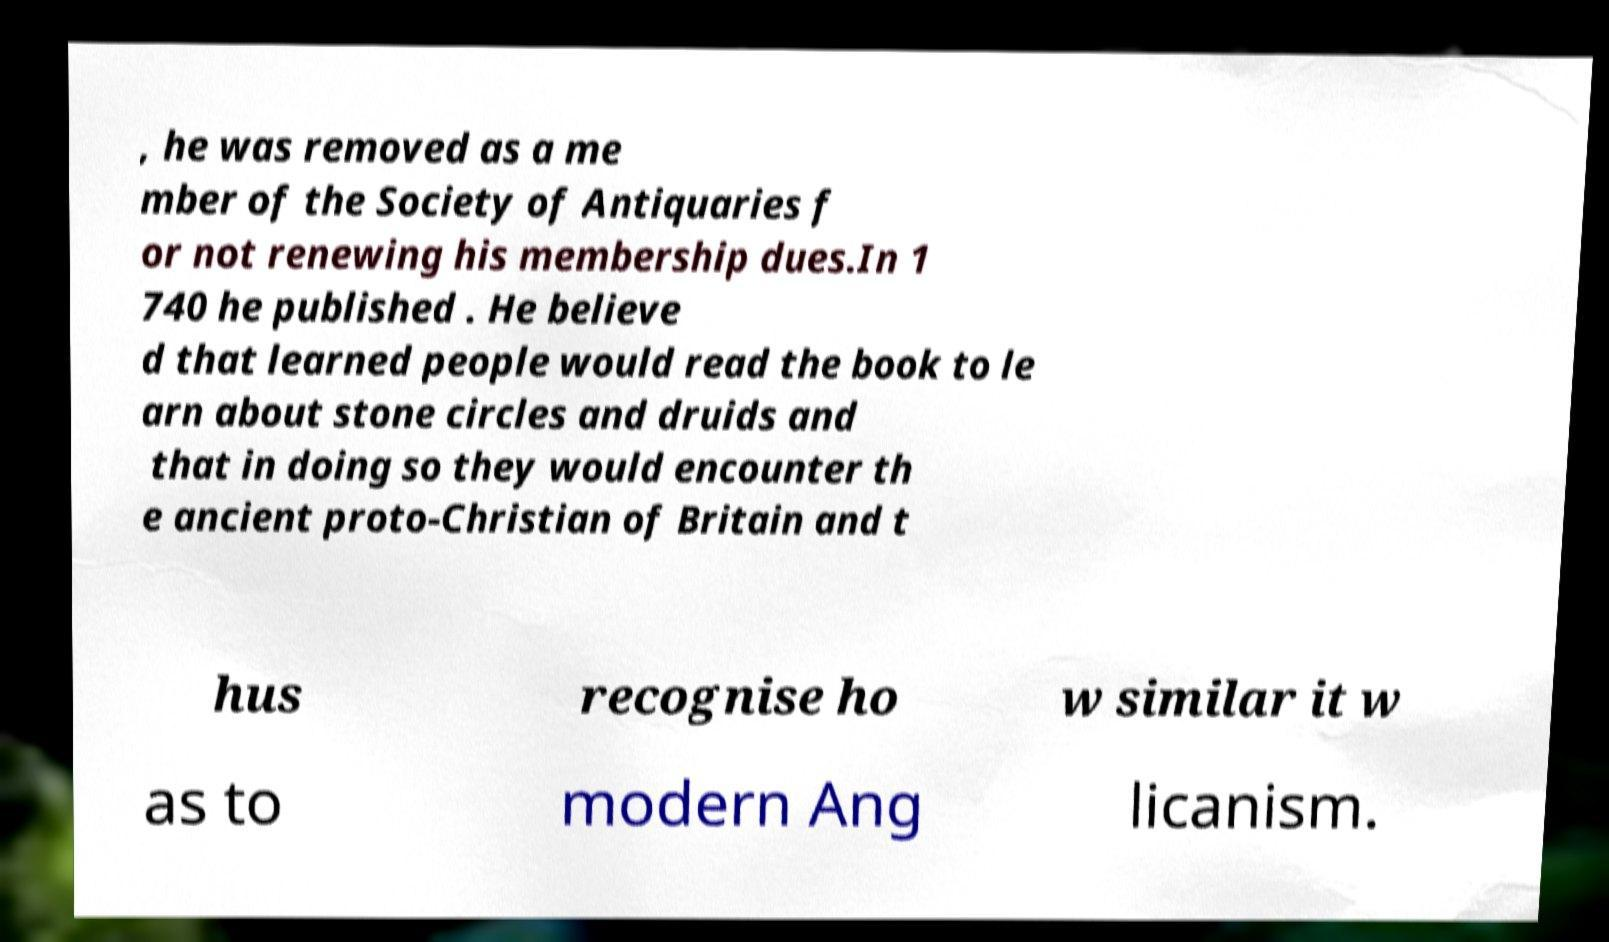Please identify and transcribe the text found in this image. , he was removed as a me mber of the Society of Antiquaries f or not renewing his membership dues.In 1 740 he published . He believe d that learned people would read the book to le arn about stone circles and druids and that in doing so they would encounter th e ancient proto-Christian of Britain and t hus recognise ho w similar it w as to modern Ang licanism. 